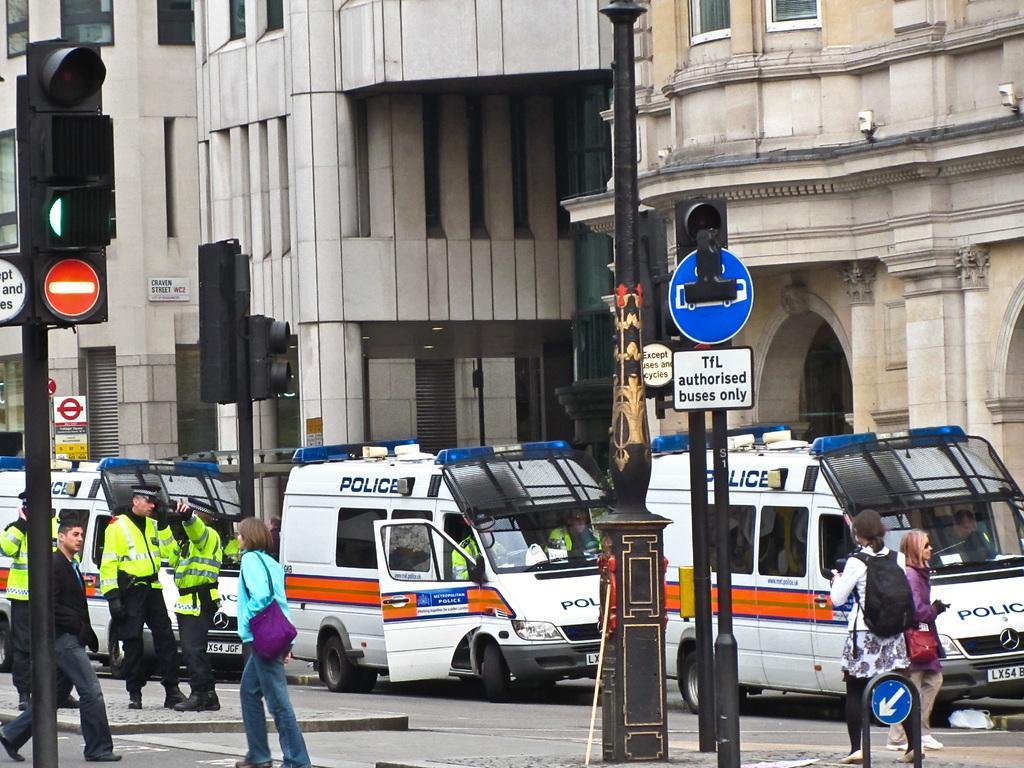Please provide a concise description of this image. This is the picture of a city. In this image there are vehicles on the road and there are group of people walking. In the foreground there are poles and there are boards and lights on the poles. At the back there is a building. At the bottom there is a road and there is a footpath. 